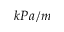<formula> <loc_0><loc_0><loc_500><loc_500>k P a / m</formula> 